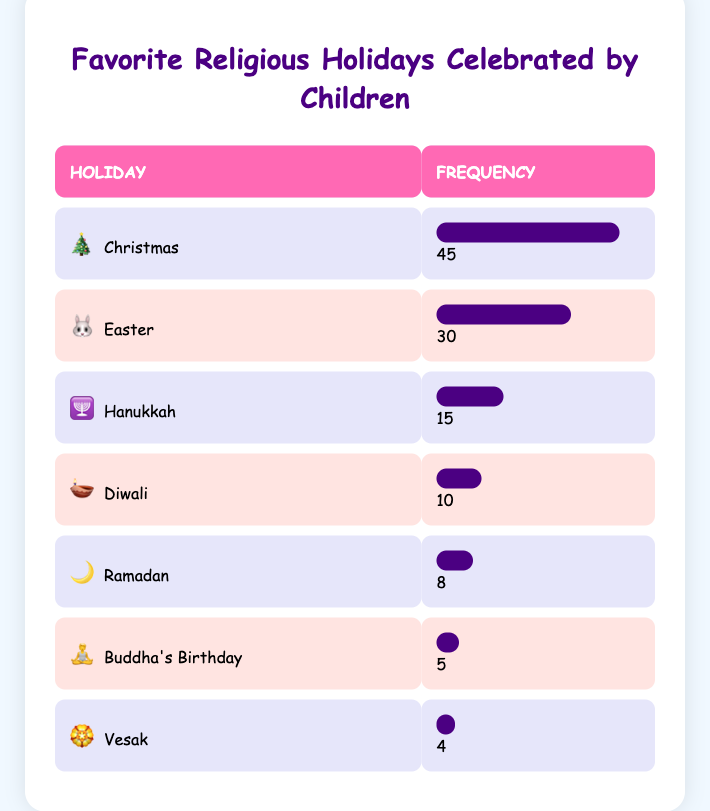What is the most favorite religious holiday celebrated by children? From the table, the holiday with the highest frequency is Christmas with a frequency of 45.
Answer: Christmas How many children celebrate Easter? The frequency of children celebrating Easter is directly stated in the table as 30.
Answer: 30 Is the frequency of children celebrating Diwali greater than that of Ramadan? The frequency of children celebrating Diwali is 10, while that of Ramadan is 8. Since 10 is greater than 8, the statement is true.
Answer: Yes What is the combined frequency of Hanukkah and Ramadan? The frequency for Hanukkah is 15 and for Ramadan is 8. Adding these together gives us 15 + 8 = 23.
Answer: 23 Which holiday has the least number of children celebrating it? The table shows that Vesak has the lowest frequency with just 4 children.
Answer: Vesak What is the average frequency of the holidays listed? To find the average, we first sum the frequencies: 45 + 30 + 15 + 10 + 8 + 5 + 4 = 117. There are 7 holidays, so the average is 117 divided by 7, which equals approximately 16.71.
Answer: Approximately 16.71 Are more children celebrating Christmas or Easter? The frequency for Christmas is 45 and for Easter is 30. Since 45 is greater than 30, more children celebrate Christmas.
Answer: Christmas If we combine the frequencies of Buddha's Birthday and Vesak, what do we get? Buddha's Birthday has a frequency of 5 and Vesak has 4. Adding these gives 5 + 4 = 9.
Answer: 9 